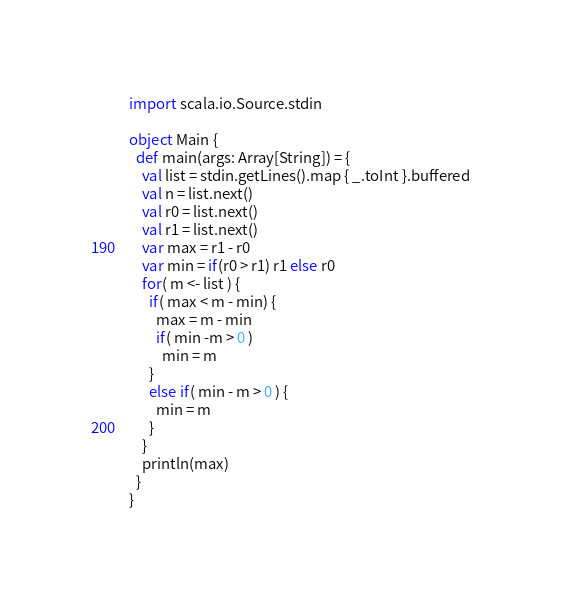Convert code to text. <code><loc_0><loc_0><loc_500><loc_500><_Scala_>import scala.io.Source.stdin

object Main {
  def main(args: Array[String]) = {
    val list = stdin.getLines().map { _.toInt }.buffered
    val n = list.next()
    val r0 = list.next()
    val r1 = list.next()
    var max = r1 - r0
    var min = if(r0 > r1) r1 else r0
    for( m <- list ) {
      if( max < m - min) {
        max = m - min
        if( min -m > 0 )
          min = m
      }
      else if( min - m > 0 ) {
        min = m
      }
    }
    println(max)
  }
}</code> 